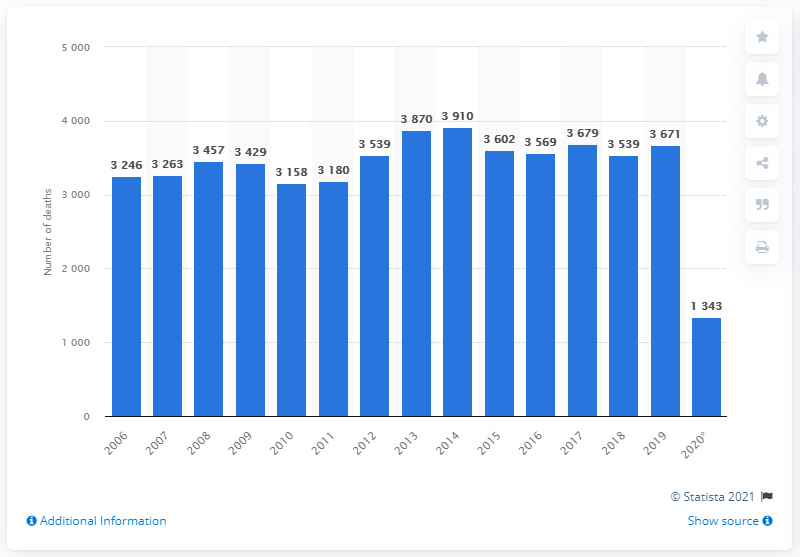Specify some key components in this picture. In 2019, there were 3,671 deaths in Spain that were caused by suicide and self-inflicted injuries. In 2014, Spain had a high suicide rate, with 3910 reported cases. In 2014, Spain had the highest suicide rate, with 39.1 per 100,000 population. 